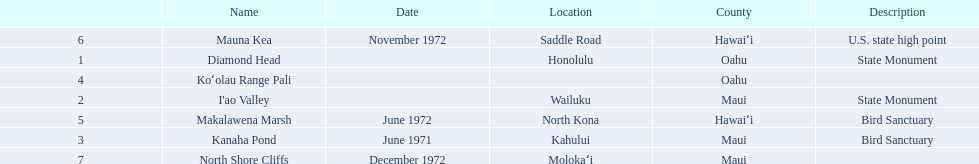What are all of the national natural landmarks in hawaii? Diamond Head, I'ao Valley, Kanaha Pond, Koʻolau Range Pali, Makalawena Marsh, Mauna Kea, North Shore Cliffs. Which ones of those national natural landmarks in hawaii are in the county of hawai'i? Makalawena Marsh, Mauna Kea. Which is the only national natural landmark in hawaii that is also a u.s. state high point? Mauna Kea. 